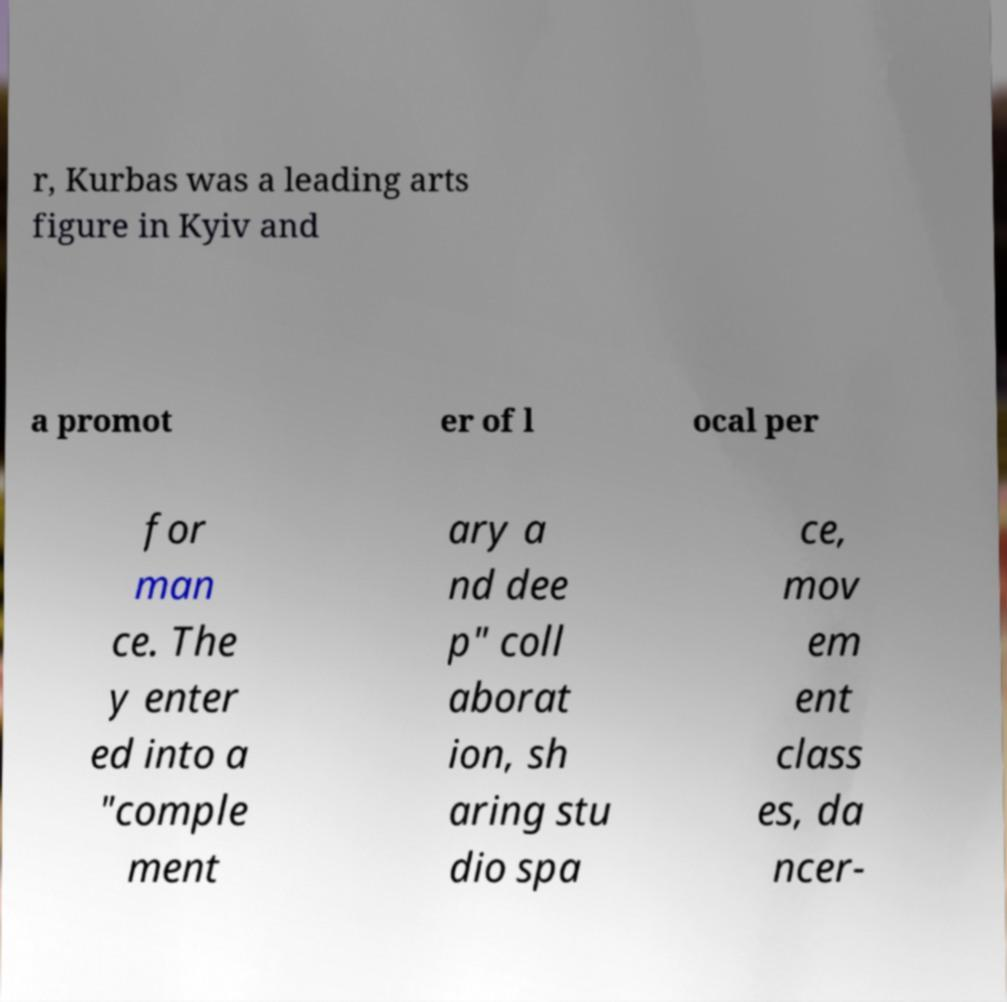There's text embedded in this image that I need extracted. Can you transcribe it verbatim? r, Kurbas was a leading arts figure in Kyiv and a promot er of l ocal per for man ce. The y enter ed into a "comple ment ary a nd dee p" coll aborat ion, sh aring stu dio spa ce, mov em ent class es, da ncer- 